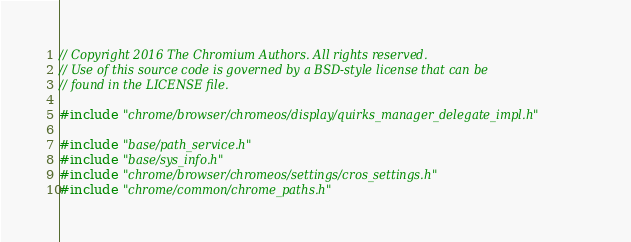<code> <loc_0><loc_0><loc_500><loc_500><_C++_>// Copyright 2016 The Chromium Authors. All rights reserved.
// Use of this source code is governed by a BSD-style license that can be
// found in the LICENSE file.

#include "chrome/browser/chromeos/display/quirks_manager_delegate_impl.h"

#include "base/path_service.h"
#include "base/sys_info.h"
#include "chrome/browser/chromeos/settings/cros_settings.h"
#include "chrome/common/chrome_paths.h"</code> 